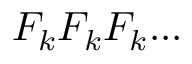Convert formula to latex. <formula><loc_0><loc_0><loc_500><loc_500>F _ { k } F _ { k } F _ { k } \dots</formula> 